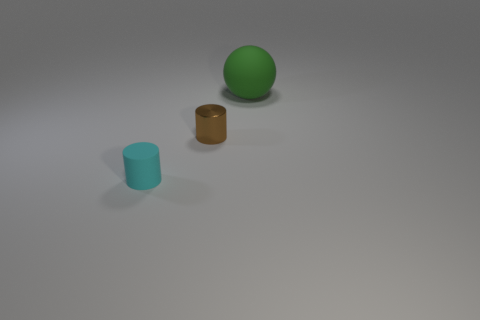Add 2 green balls. How many objects exist? 5 Subtract all balls. How many objects are left? 2 Subtract 0 purple cylinders. How many objects are left? 3 Subtract all cyan things. Subtract all tiny brown shiny objects. How many objects are left? 1 Add 2 green rubber balls. How many green rubber balls are left? 3 Add 2 cyan objects. How many cyan objects exist? 3 